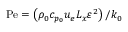Convert formula to latex. <formula><loc_0><loc_0><loc_500><loc_500>P e = \left ( \rho _ { 0 } c _ { p _ { 0 } } u _ { e } L _ { x } \varepsilon ^ { 2 } \right ) \Big / k _ { 0 }</formula> 